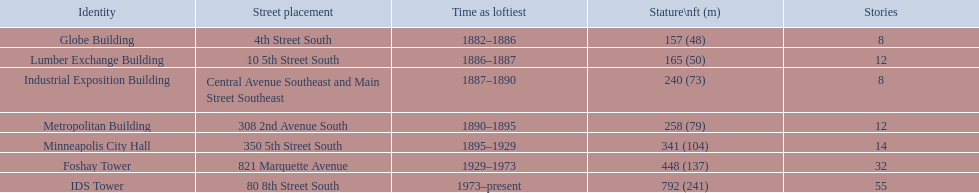Is the metropolitan building or the lumber exchange building taller? Metropolitan Building. 